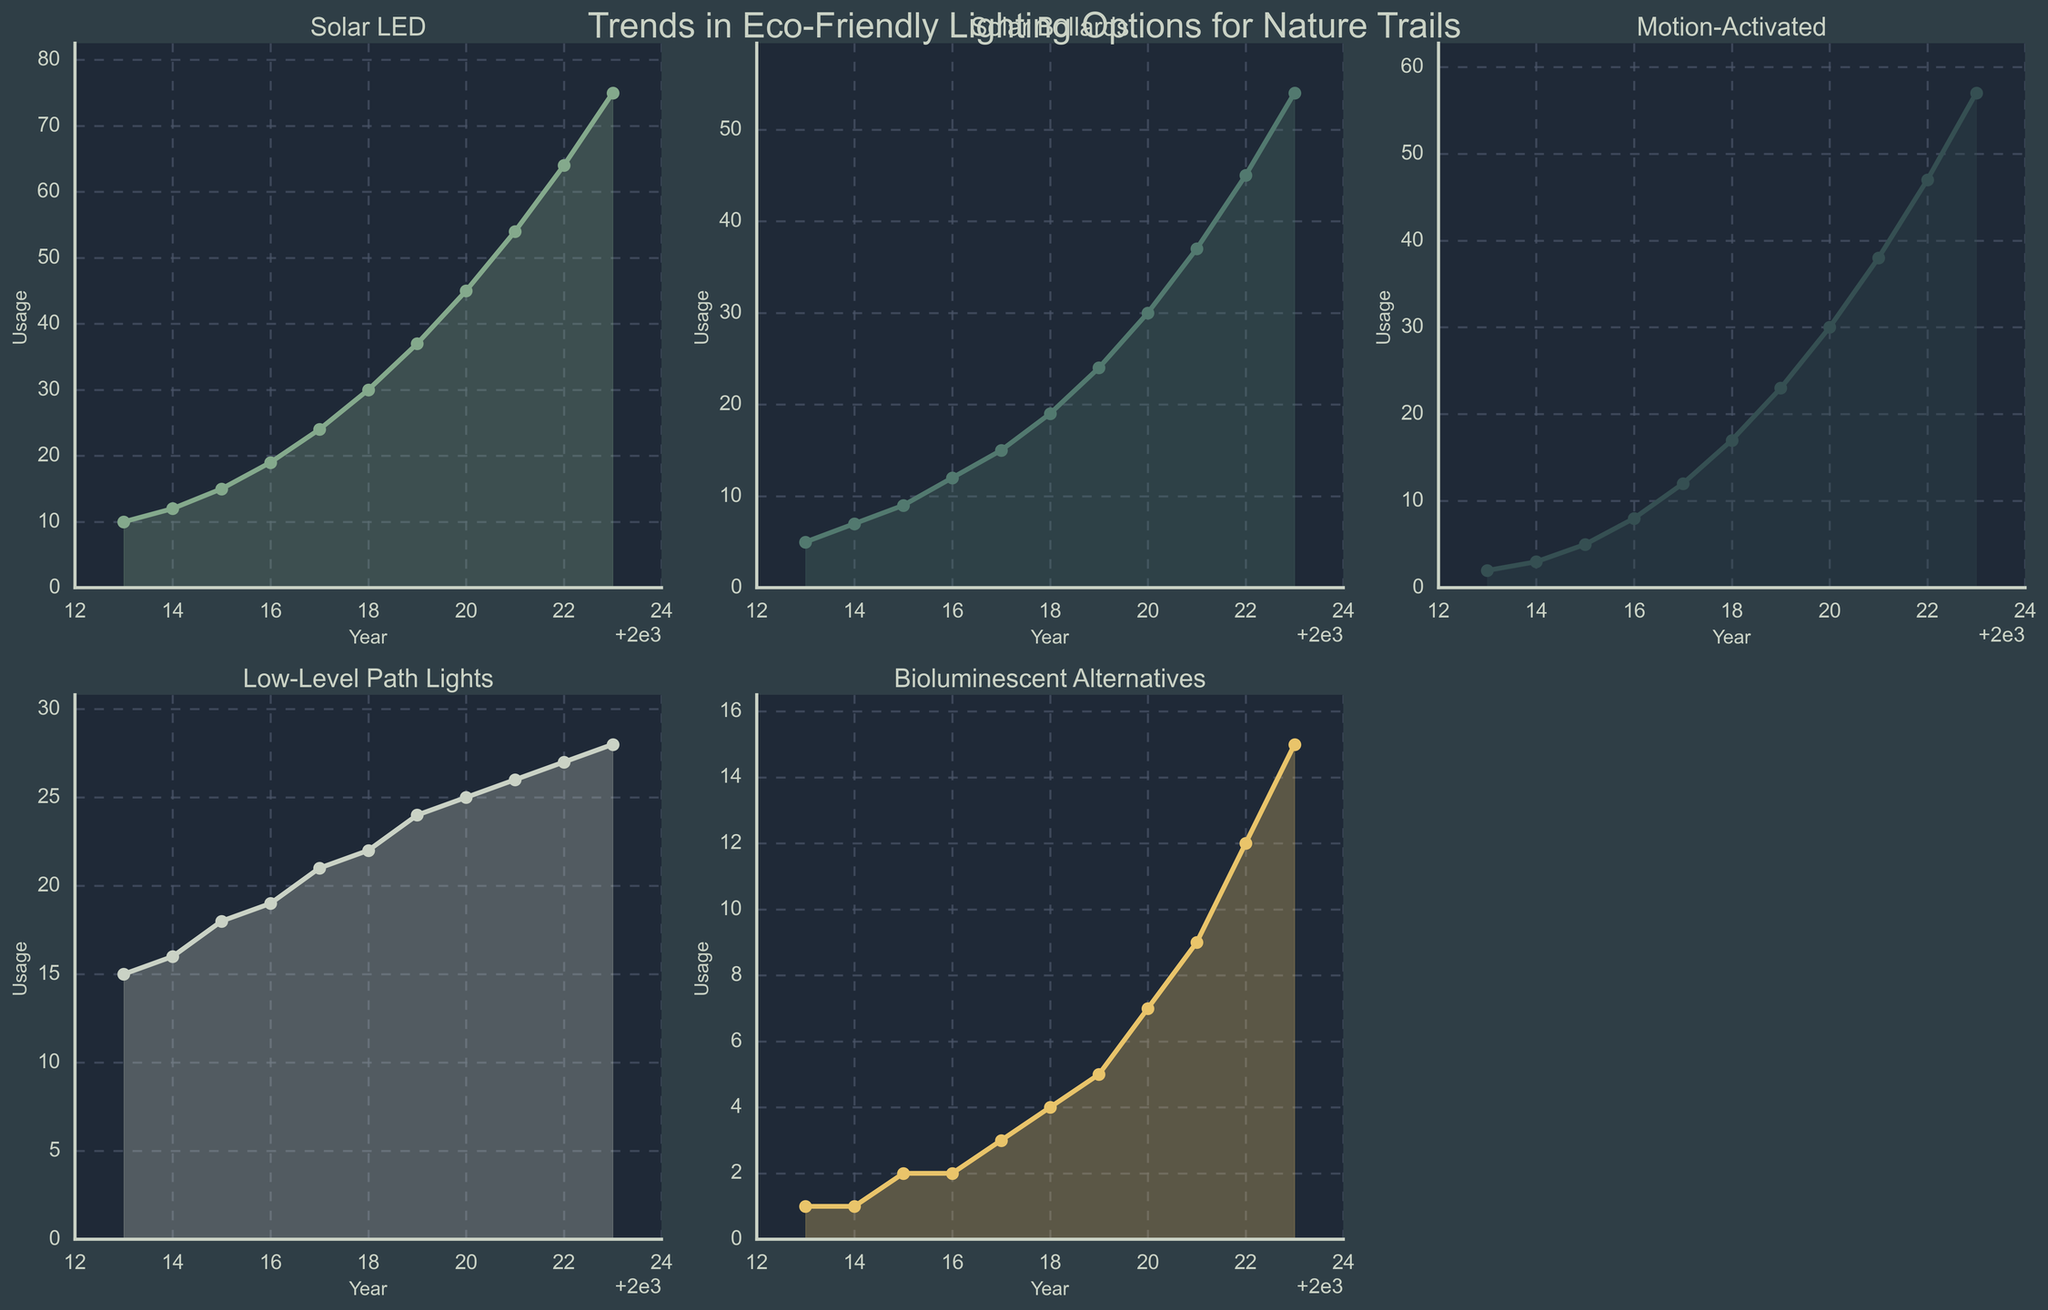what’s the overall trend for the Solar LED lighting option from 2013 to 2023? From the plot, we can see that the line corresponding to Solar LED lighting has a generally upward trajectory from 2013 to 2023, indicating an increasing trend in its usage.
Answer: Increasing trend Which lighting option had the highest usage in 2023? Looking at the endpoint of each plot for the year 2023, the Solar LED line is the highest, indicating that Solar LED had the highest usage.
Answer: Solar LED Did Bioluminescent Alternatives ever surpass the usage of Solar Bollards over the decade? By comparing the heights of the Bioluminescent Alternatives and Solar Bollards lines for each year, we see that Bioluminescent Alternatives' usage never surpasses the usage of Solar Bollards in any year.
Answer: No What's the mean usage of Low-Level Path Lights over the decade? The usage values for Low-Level Path Lights from 2013 to 2023 are summed up (15 + 16 + 18 + 19 + 21 + 22 + 24 + 25 + 26 + 27 + 28 = 241) and averaged over 11 years. The mean is 241 / 11 ≈ 21.91
Answer: Approximately 21.91 Compare the growth in usage between Motion-Activated and Solar Bollards from 2013 to 2023. Which grew more? The initial usage for Motion-Activated in 2013 is 2 and in 2023 is 57, therefore the growth is 55 (57 - 2). For Solar Bollards, the initial usage is 5 and in 2023 is 54, therefore, the growth is 49 (54 - 5). Comparing the growth values, Motion-Activated grew more.
Answer: Motion-Activated At what year did Solar LED lighting surpass the usage of Low-Level Path Lights? Looking at the intersection point of the lines for Solar LED and Low-Level Path Lights, Solar LED surpassed Low-Level Path Lights usage between 2015 and 2016.
Answer: 2016 Which lighting option showed the least growth over the decade? By comparing the start and end points (growth) for all lighting options, Bioluminescent Alternatives grew from 1 to 15, indicating the smallest growth among all options.
Answer: Bioluminescent Alternatives In which year did all types of lighting show an increase compared to the previous year? Referring to the figure, in 2017, all lighting options show an increase in usage compared to 2016.
Answer: 2017 